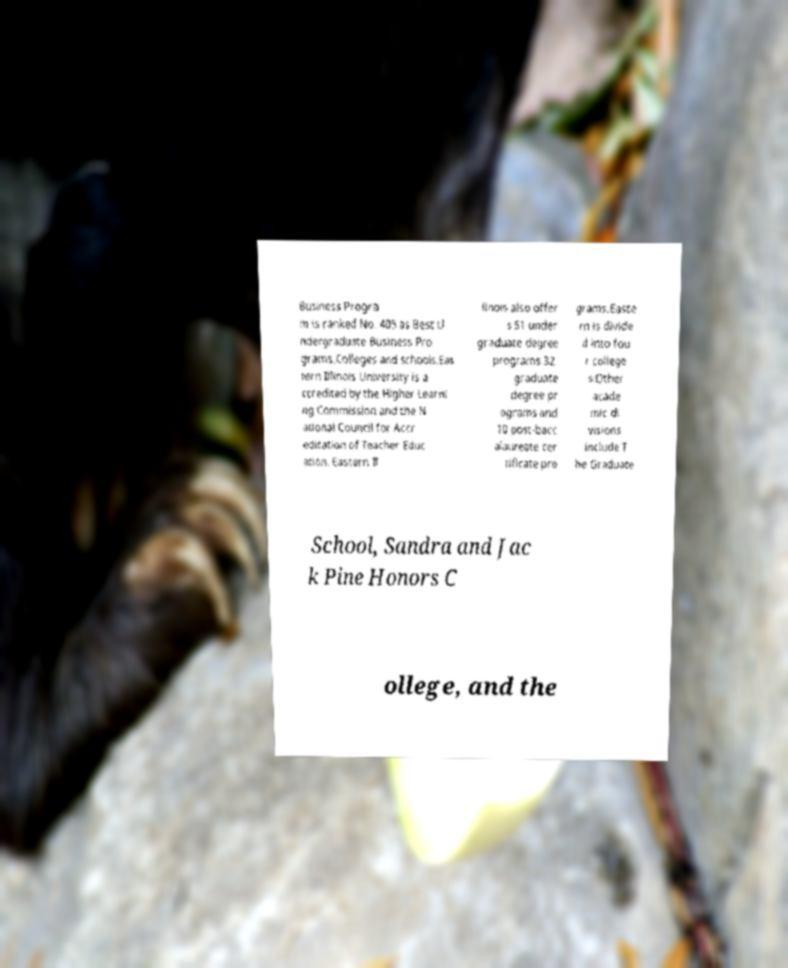Can you accurately transcribe the text from the provided image for me? Business Progra m is ranked No. 405 as Best U ndergraduate Business Pro grams.Colleges and schools.Eas tern Illinois University is a ccredited by the Higher Learni ng Commission and the N ational Council for Accr editation of Teacher Educ ation. Eastern Il linois also offer s 51 under graduate degree programs 32 graduate degree pr ograms and 10 post-bacc alaureate cer tificate pro grams.Easte rn is divide d into fou r college s:Other acade mic di visions include T he Graduate School, Sandra and Jac k Pine Honors C ollege, and the 